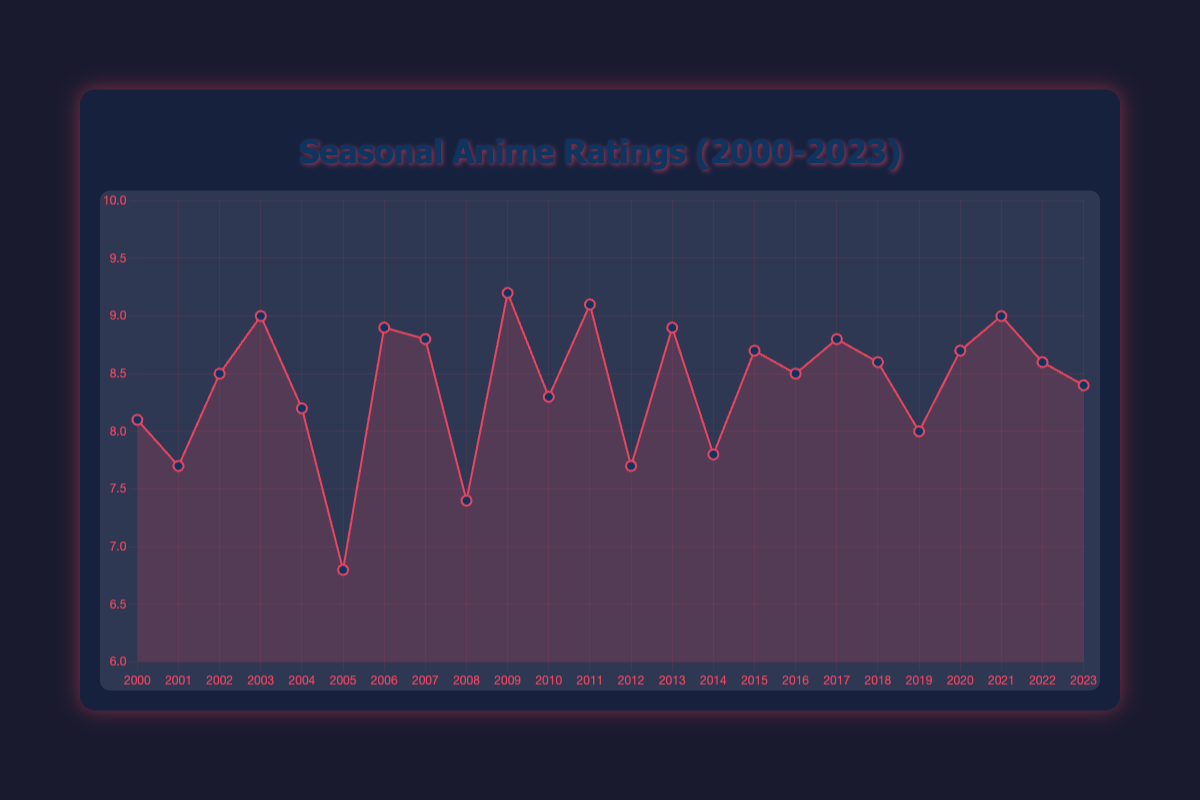What year had the highest anime rating, and what was the anime title? By observing the highest point on the graph, we can see that the peak rating occurs in 2009. The tooltip reveals the anime title for 2009 was "Fullmetal Alchemist: Brotherhood" with a rating of 9.2.
Answer: 2009, Fullmetal Alchemist: Brotherhood Compare the ratings of "Naruto" and "Bleach". Which one is higher and by how much? "Naruto" has a rating of 8.5, and "Bleach" has a rating of 8.2. The difference is calculated as 8.5 - 8.2, which is 0.3.
Answer: "Naruto" by 0.3 Which anime has the lowest rating, and what was its rating? The lowest point on the chart is in 2005 with the rating of "Tales of Phantasia: The Animation," which has a rating of 6.8.
Answer: Tales of Phantasia: The Animation, 6.8 What is the average rating of all the anime from 2000 to 2023? Sum of all ratings divided by the number of years: (8.1 + 7.7 + 8.5 + 9.0 + 8.2 + 6.8 + 8.9 + 8.8 + 7.4 + 9.2 + 8.3 + 9.1 + 7.7 + 8.9 + 7.8 + 8.7 + 8.5 + 8.8 + 8.6 + 8.0 + 8.7 + 9.0 + 8.6 + 8.4) / 24 = 8.34
Answer: 8.34 How many animes had a rating equal to or above 9.0? By checking all points on the chart that have a rating of 9.0 or higher, we identify "Fullmetal Alchemist," "Fullmetal Alchemist: Brotherhood," "Steins;Gate," and "Demon Slayer: Kimetsu no Yaiba - Entertainment District Arc," totaling 4 animes.
Answer: 4 Did the rating improve or decline from 2000 to 2001 and by how much? The rating in 2000 for "Digimon Adventure 02" was 8.1, and in 2001 for "Shaman King" was 7.7. The change is calculated as 7.7 - 8.1, resulting in a decline of 0.4.
Answer: Decline by 0.4 Which anime had a rating of 8.7, and in which years did this occur? By observing the chart, the anime with an 8.7 rating are "One Punch Man" in 2015 and "Jujutsu Kaisen" in 2020.
Answer: One Punch Man (2015), Jujutsu Kaisen (2020) What is the difference in rating between "Attack on Titan" (2013) and "Tokyo Ghoul" (2014)? "Attack on Titan" has a rating of 8.9 (2013) and "Tokyo Ghoul" has a rating of 7.8 (2014). The difference is 8.9 - 7.8 = 1.1.
Answer: 1.1 